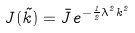<formula> <loc_0><loc_0><loc_500><loc_500>J ( \vec { k } ) = { \bar { J } } e ^ { - { \frac { 1 } { 2 } } \lambda ^ { 2 } k ^ { 2 } }</formula> 